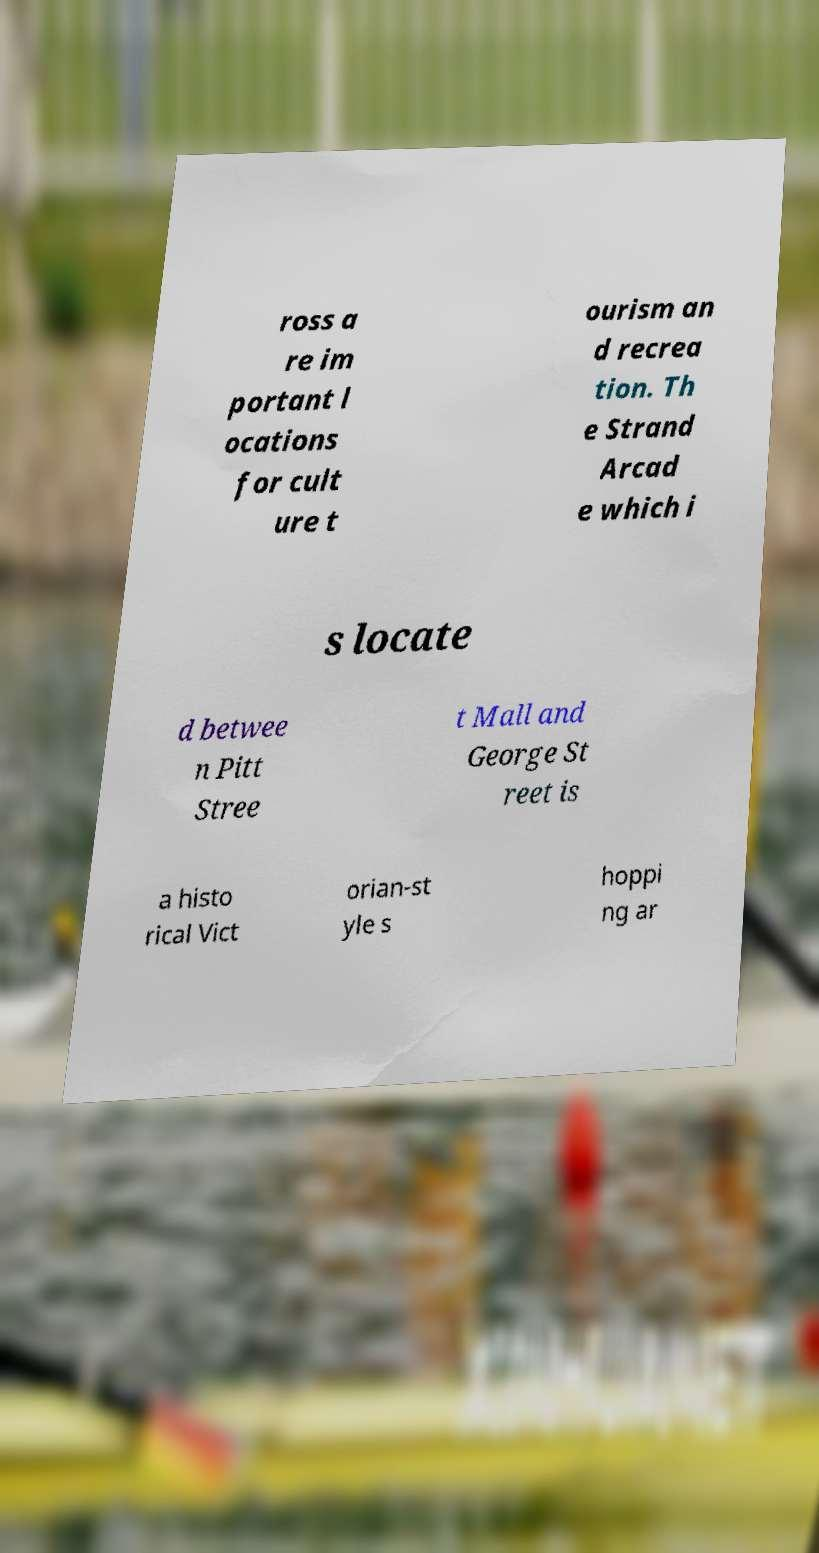Could you extract and type out the text from this image? ross a re im portant l ocations for cult ure t ourism an d recrea tion. Th e Strand Arcad e which i s locate d betwee n Pitt Stree t Mall and George St reet is a histo rical Vict orian-st yle s hoppi ng ar 